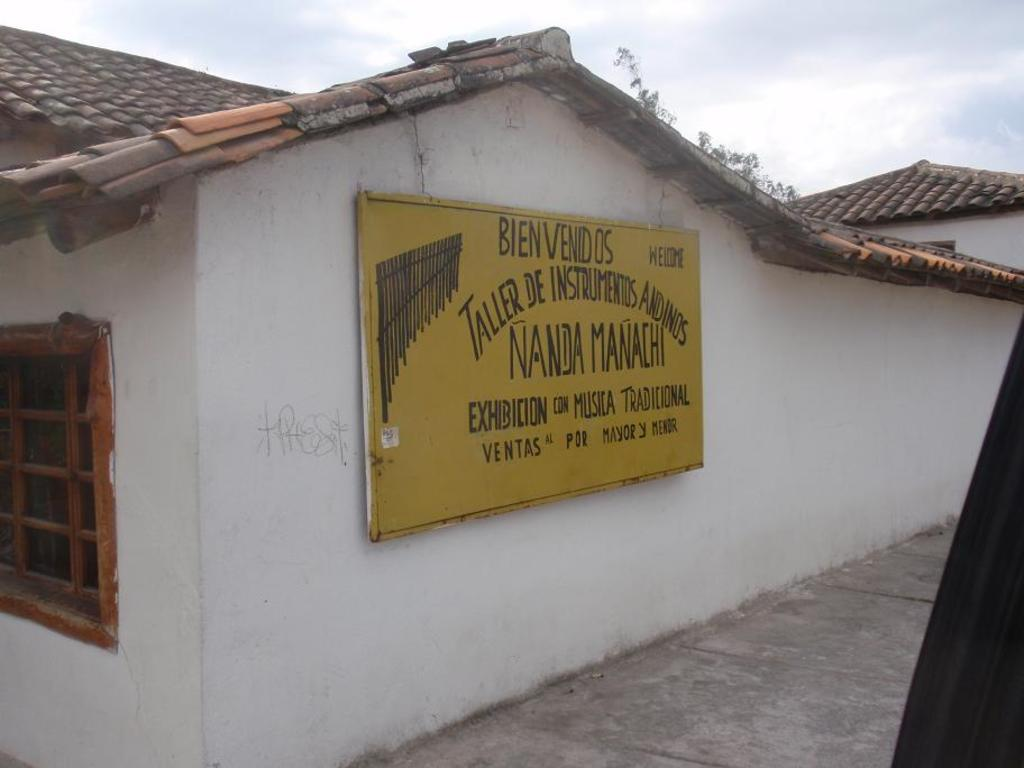<image>
Offer a succinct explanation of the picture presented. Sign on a building that says "Bien Venidos" on top. 